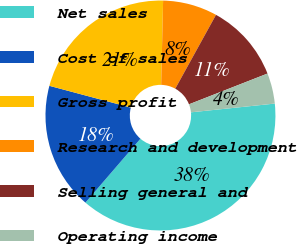Convert chart. <chart><loc_0><loc_0><loc_500><loc_500><pie_chart><fcel>Net sales<fcel>Cost of sales<fcel>Gross profit<fcel>Research and development<fcel>Selling general and<fcel>Operating income<nl><fcel>37.97%<fcel>17.84%<fcel>21.21%<fcel>7.66%<fcel>11.03%<fcel>4.29%<nl></chart> 